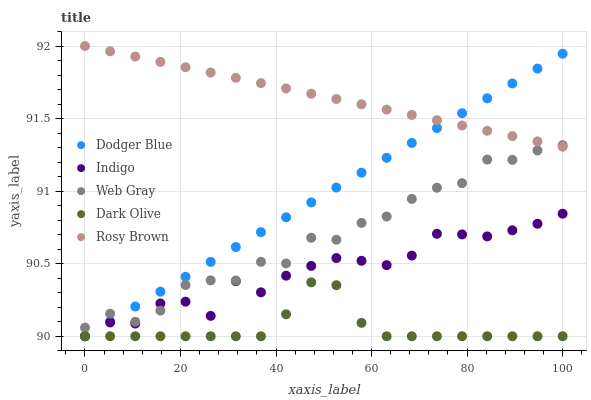Does Dark Olive have the minimum area under the curve?
Answer yes or no. Yes. Does Rosy Brown have the maximum area under the curve?
Answer yes or no. Yes. Does Indigo have the minimum area under the curve?
Answer yes or no. No. Does Indigo have the maximum area under the curve?
Answer yes or no. No. Is Rosy Brown the smoothest?
Answer yes or no. Yes. Is Web Gray the roughest?
Answer yes or no. Yes. Is Indigo the smoothest?
Answer yes or no. No. Is Indigo the roughest?
Answer yes or no. No. Does Dark Olive have the lowest value?
Answer yes or no. Yes. Does Rosy Brown have the lowest value?
Answer yes or no. No. Does Rosy Brown have the highest value?
Answer yes or no. Yes. Does Indigo have the highest value?
Answer yes or no. No. Is Dark Olive less than Web Gray?
Answer yes or no. Yes. Is Web Gray greater than Dark Olive?
Answer yes or no. Yes. Does Indigo intersect Web Gray?
Answer yes or no. Yes. Is Indigo less than Web Gray?
Answer yes or no. No. Is Indigo greater than Web Gray?
Answer yes or no. No. Does Dark Olive intersect Web Gray?
Answer yes or no. No. 